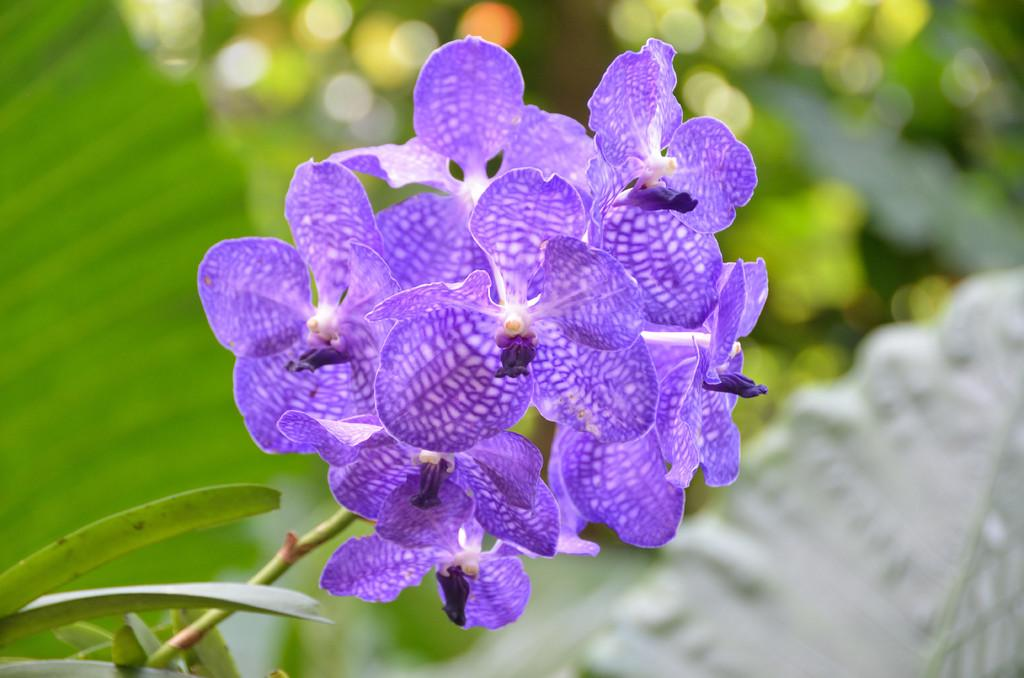What is the main subject of the image? The main subject of the image is a group of flowers. What are the flowers connected to? The flowers are associated with plants. What other parts of the plants can be seen in the image? Leaves are visible in the image. What type of juice can be seen dripping from the flowers in the image? There is no juice visible in the image; it features a group of flowers and leaves. How many bikes are parked near the flowers in the image? There are no bikes present in the image. 